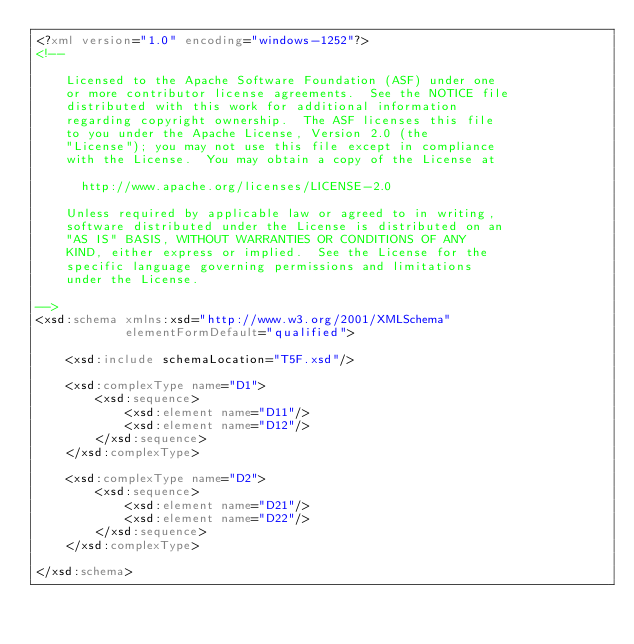Convert code to text. <code><loc_0><loc_0><loc_500><loc_500><_XML_><?xml version="1.0" encoding="windows-1252"?>
<!--

    Licensed to the Apache Software Foundation (ASF) under one
    or more contributor license agreements.  See the NOTICE file
    distributed with this work for additional information
    regarding copyright ownership.  The ASF licenses this file
    to you under the Apache License, Version 2.0 (the
    "License"); you may not use this file except in compliance
    with the License.  You may obtain a copy of the License at

      http://www.apache.org/licenses/LICENSE-2.0

    Unless required by applicable law or agreed to in writing,
    software distributed under the License is distributed on an
    "AS IS" BASIS, WITHOUT WARRANTIES OR CONDITIONS OF ANY
    KIND, either express or implied.  See the License for the
    specific language governing permissions and limitations
    under the License.

-->
<xsd:schema xmlns:xsd="http://www.w3.org/2001/XMLSchema"            
            elementFormDefault="qualified">

    <xsd:include schemaLocation="T5F.xsd"/>

    <xsd:complexType name="D1">
        <xsd:sequence>
            <xsd:element name="D11"/>
            <xsd:element name="D12"/>
        </xsd:sequence>
    </xsd:complexType>

    <xsd:complexType name="D2">
        <xsd:sequence>
            <xsd:element name="D21"/>
            <xsd:element name="D22"/>
        </xsd:sequence>
    </xsd:complexType>

</xsd:schema>
</code> 